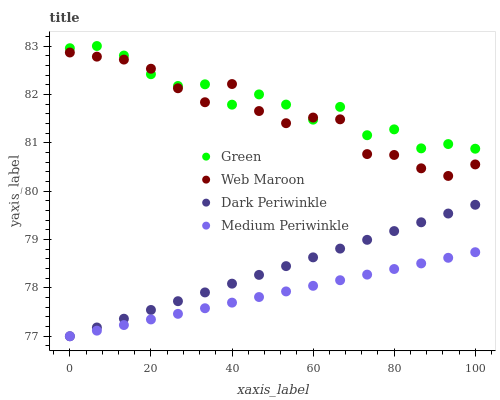Does Medium Periwinkle have the minimum area under the curve?
Answer yes or no. Yes. Does Green have the maximum area under the curve?
Answer yes or no. Yes. Does Dark Periwinkle have the minimum area under the curve?
Answer yes or no. No. Does Dark Periwinkle have the maximum area under the curve?
Answer yes or no. No. Is Dark Periwinkle the smoothest?
Answer yes or no. Yes. Is Green the roughest?
Answer yes or no. Yes. Is Green the smoothest?
Answer yes or no. No. Is Dark Periwinkle the roughest?
Answer yes or no. No. Does Dark Periwinkle have the lowest value?
Answer yes or no. Yes. Does Green have the lowest value?
Answer yes or no. No. Does Green have the highest value?
Answer yes or no. Yes. Does Dark Periwinkle have the highest value?
Answer yes or no. No. Is Medium Periwinkle less than Green?
Answer yes or no. Yes. Is Web Maroon greater than Dark Periwinkle?
Answer yes or no. Yes. Does Green intersect Web Maroon?
Answer yes or no. Yes. Is Green less than Web Maroon?
Answer yes or no. No. Is Green greater than Web Maroon?
Answer yes or no. No. Does Medium Periwinkle intersect Green?
Answer yes or no. No. 